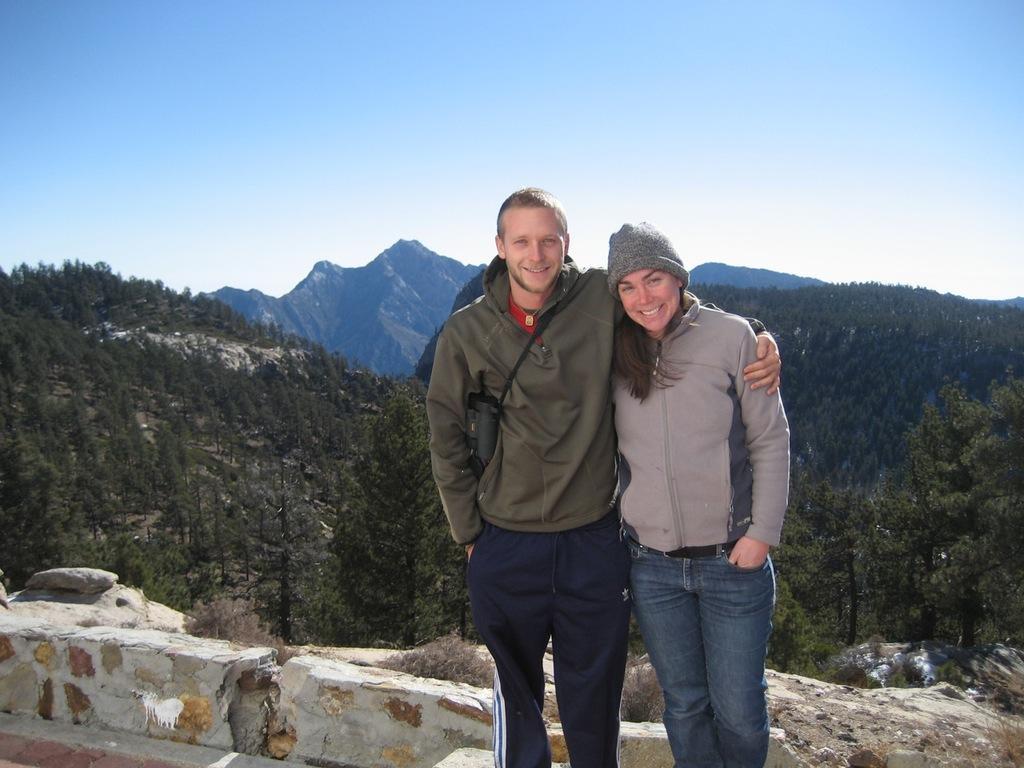Could you give a brief overview of what you see in this image? In this image I can see a man and a woman are wearing jackets, jeans, standing, smiling and giving pose for the picture. In the background there are some trees and hills. On the top of the image I can see the sky. 